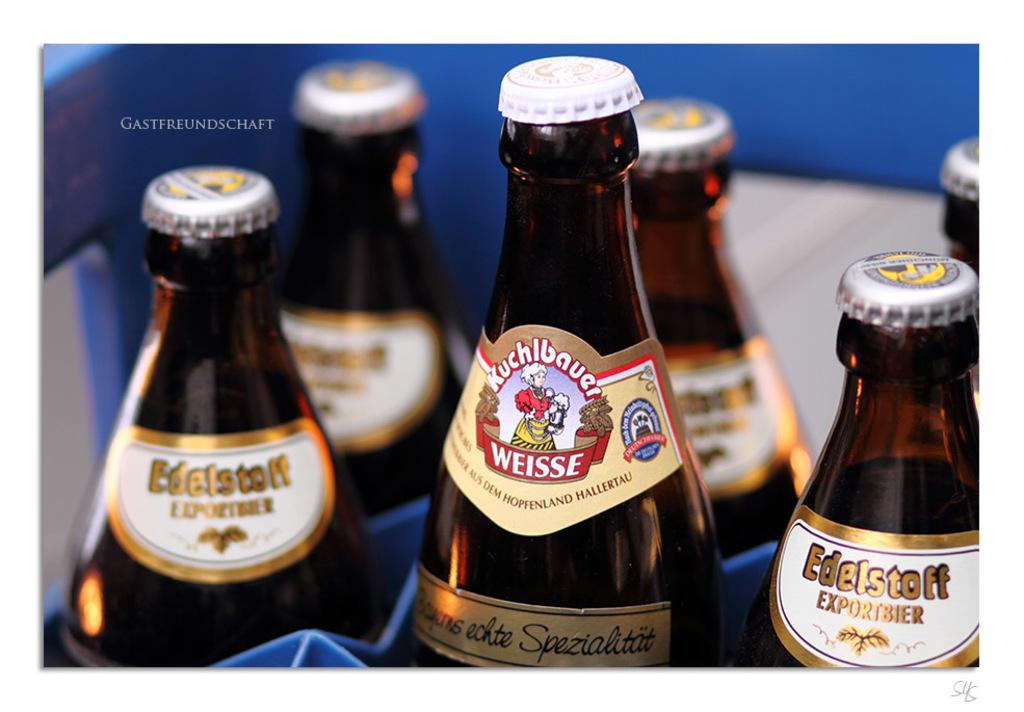<image>
Relay a brief, clear account of the picture shown. 6 beer bottles can be seen with the largest one from Kuchlbauer Weisse. 